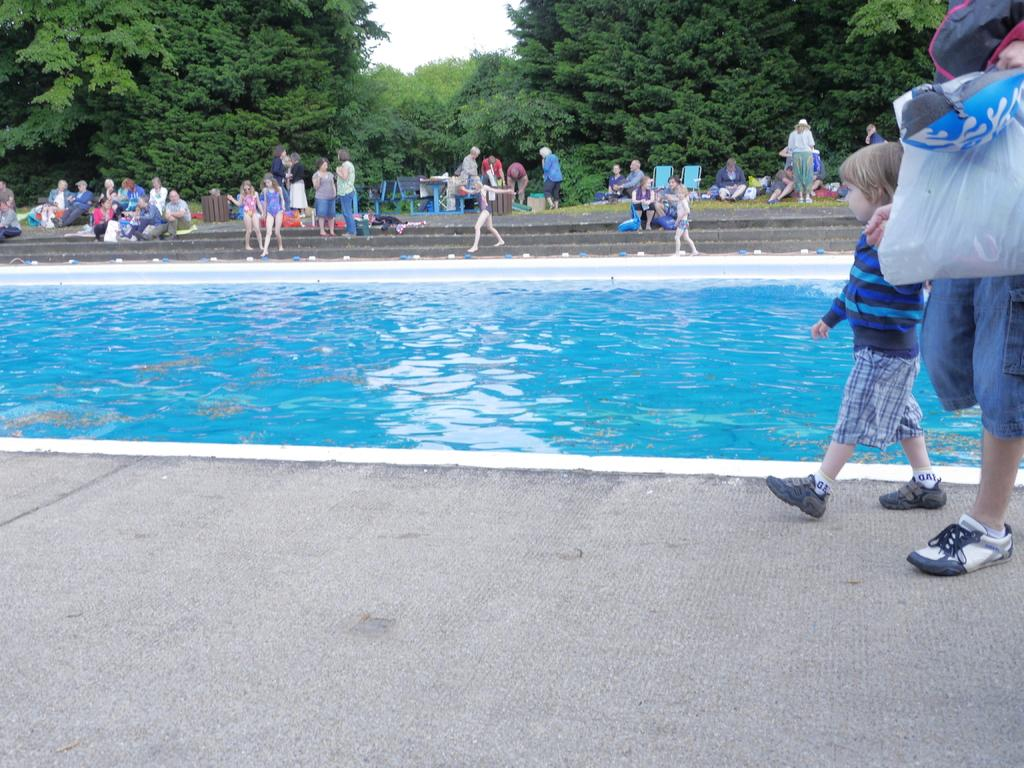What type of vegetation can be seen in the image? There are trees in the image. What part of the natural environment is visible in the image? The sky is visible in the image. What are the people in the image doing? There are persons standing on the ground and sitting on the stairs in the image. What type of water feature is present in the image? There is a swimming pool in the image. What type of railway can be seen in the image? There is no railway present in the image. Can you hear the sound of the sidewalk in the image? The image is a visual representation and does not include sound, so it is not possible to hear the sound of the sidewalk. 